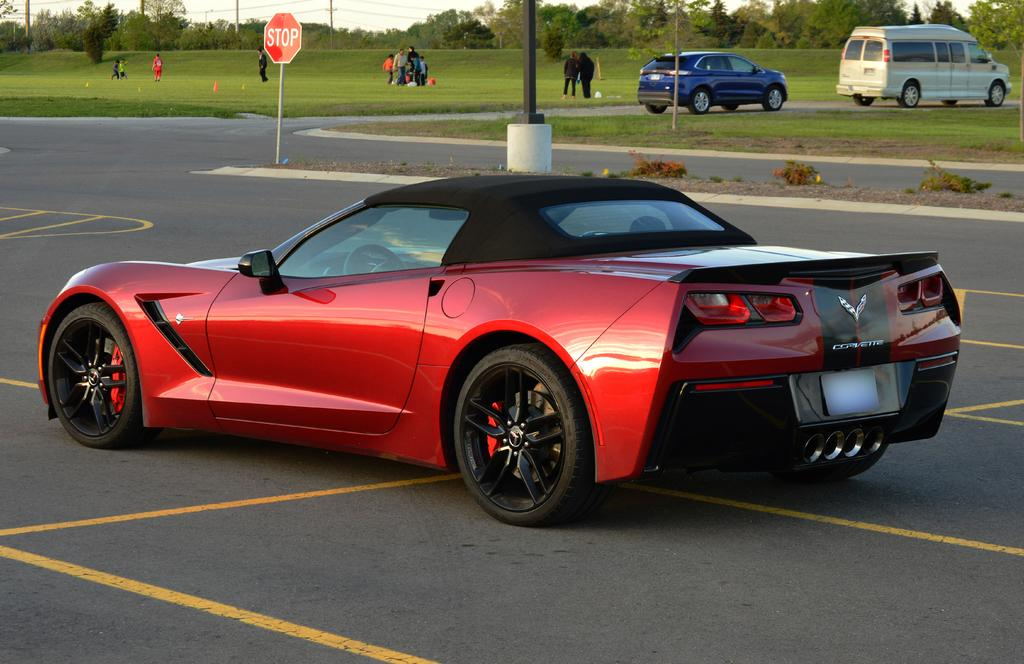What type of objects are on the ground in the image? There are vehicles on the ground in the image. Where are the vehicles located? The vehicles are on the ground. What type of vegetation can be seen in the image? There is grass visible in the image. Who or what else is present in the image? There are people in the image. What else can be seen in the image besides vehicles, grass, and people? There are trees and poles in the image. What type of humor is being displayed by the suit in the image? There is no suit present in the image, and therefore no humor can be attributed to it. 